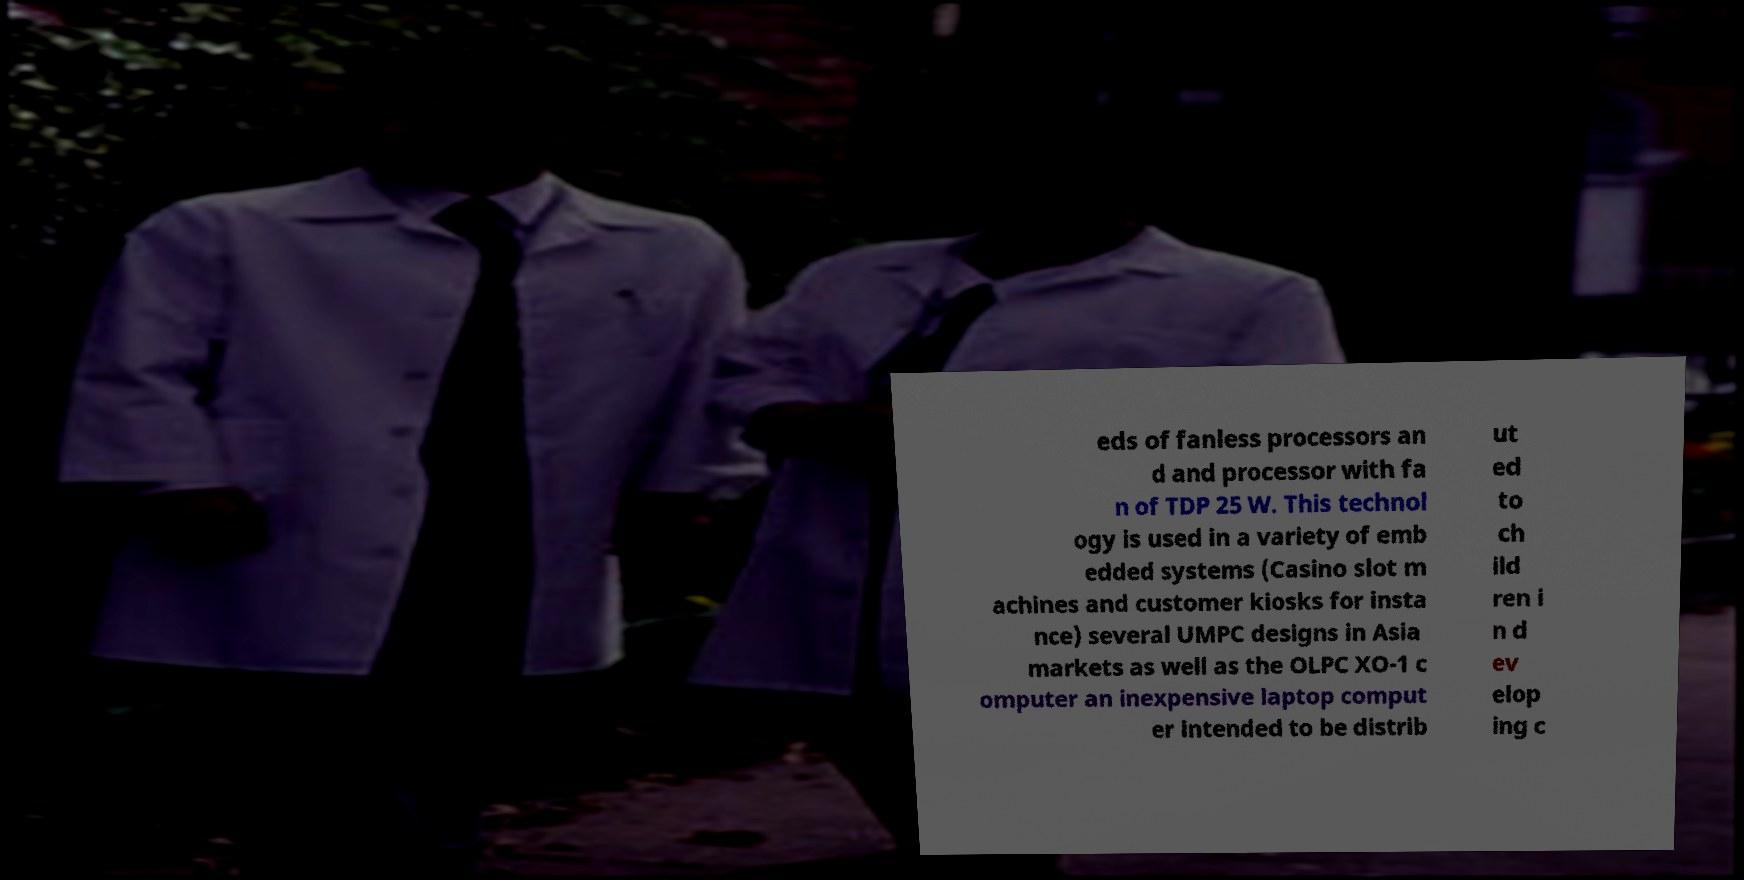Can you accurately transcribe the text from the provided image for me? eds of fanless processors an d and processor with fa n of TDP 25 W. This technol ogy is used in a variety of emb edded systems (Casino slot m achines and customer kiosks for insta nce) several UMPC designs in Asia markets as well as the OLPC XO-1 c omputer an inexpensive laptop comput er intended to be distrib ut ed to ch ild ren i n d ev elop ing c 